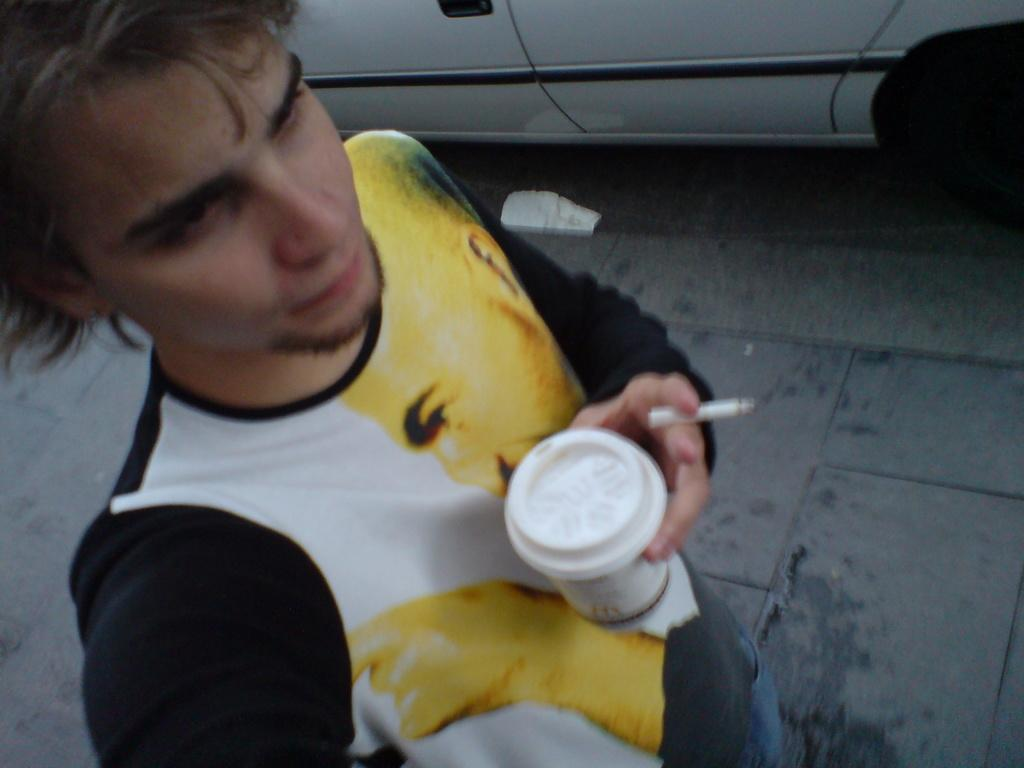What is the person in the image doing? The person is standing in the image. What is the person holding in his hand? The person is holding a cigarette and another object in his hand. What can be seen near the person in the image? There is a car beside the person in the image. What type of voyage is the person embarking on in the image? There is no indication of a voyage in the image; it simply shows a person standing with a cigarette and another object in his hand, and a car nearby. 